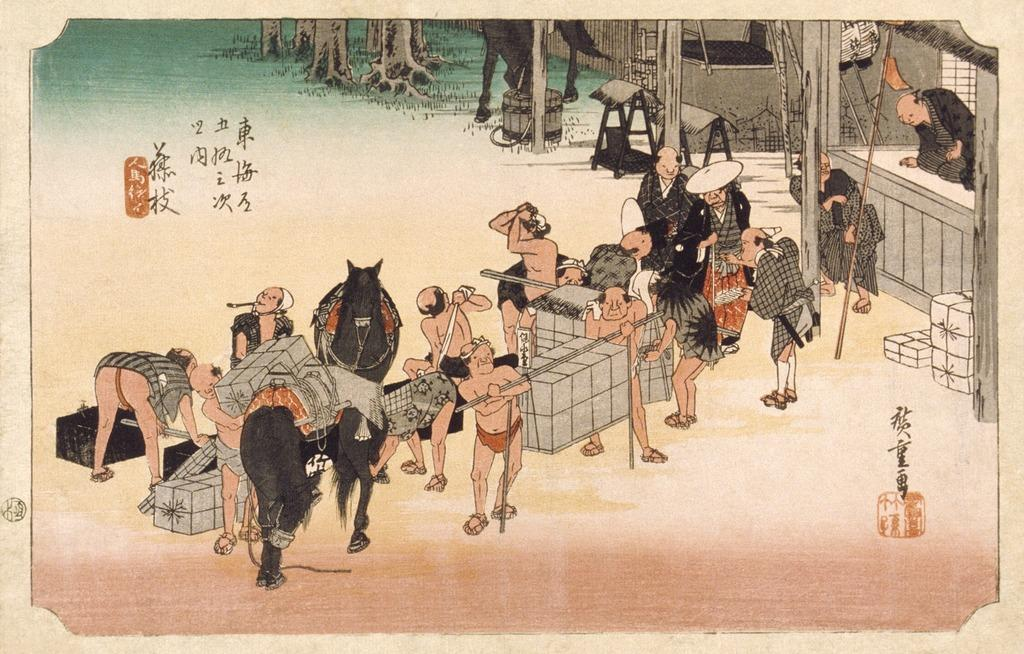What type of artwork is depicted in the image? The image is a painting. What is the main subject of the painting? There is a group of people in the painting. What architectural feature is present in the painting? There is a wall in the painting. What type of structure can be seen in the painting? There are poles in the painting. How many boats are visible in the painting? There are no boats present in the painting; it features a group of people, a wall, and poles. What type of beef is being cooked in the painting? There is no beef or any food being cooked in the painting; it primarily focuses on the group of people and the surrounding structures. 